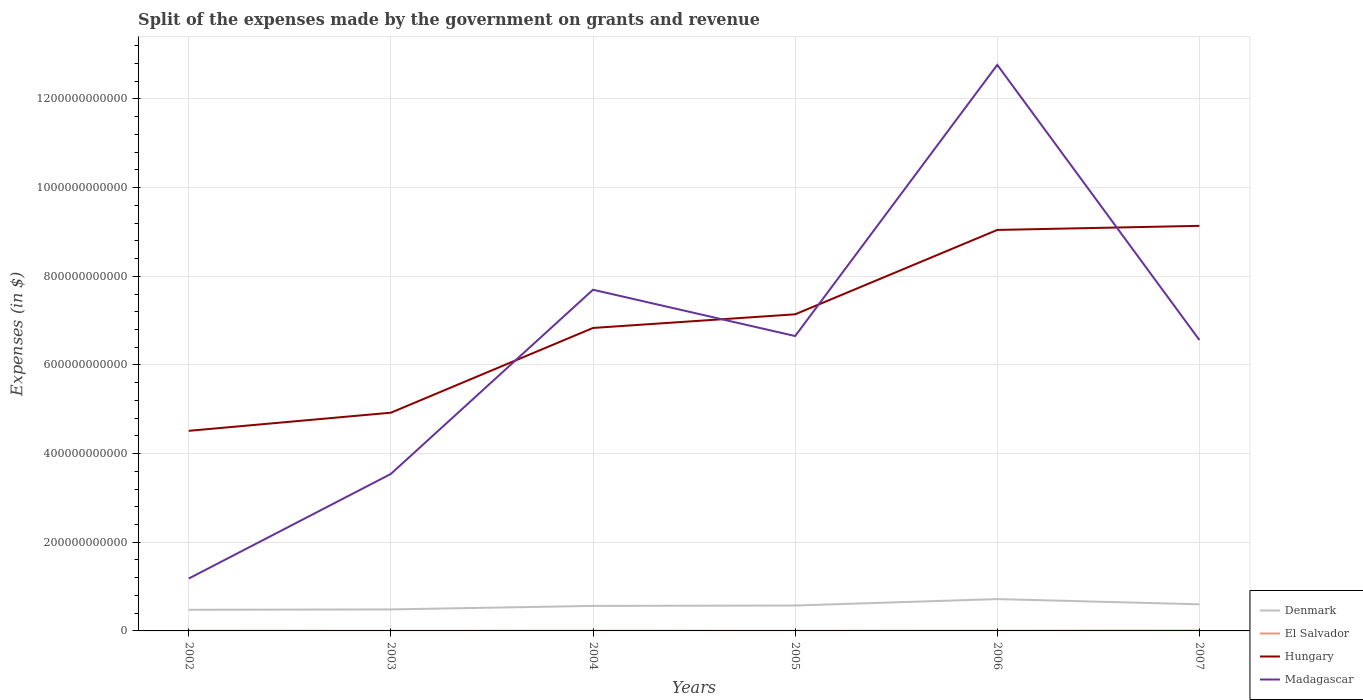How many different coloured lines are there?
Ensure brevity in your answer.  4. Across all years, what is the maximum expenses made by the government on grants and revenue in Madagascar?
Your answer should be compact. 1.18e+11. In which year was the expenses made by the government on grants and revenue in Denmark maximum?
Make the answer very short. 2002. What is the total expenses made by the government on grants and revenue in Denmark in the graph?
Offer a terse response. -1.24e+1. What is the difference between the highest and the second highest expenses made by the government on grants and revenue in Denmark?
Keep it short and to the point. 2.41e+1. How many years are there in the graph?
Keep it short and to the point. 6. What is the difference between two consecutive major ticks on the Y-axis?
Offer a terse response. 2.00e+11. Are the values on the major ticks of Y-axis written in scientific E-notation?
Make the answer very short. No. Where does the legend appear in the graph?
Provide a short and direct response. Bottom right. What is the title of the graph?
Provide a succinct answer. Split of the expenses made by the government on grants and revenue. Does "Puerto Rico" appear as one of the legend labels in the graph?
Your answer should be very brief. No. What is the label or title of the X-axis?
Keep it short and to the point. Years. What is the label or title of the Y-axis?
Your response must be concise. Expenses (in $). What is the Expenses (in $) of Denmark in 2002?
Offer a terse response. 4.77e+1. What is the Expenses (in $) of El Salvador in 2002?
Make the answer very short. 4.32e+08. What is the Expenses (in $) in Hungary in 2002?
Offer a terse response. 4.51e+11. What is the Expenses (in $) in Madagascar in 2002?
Give a very brief answer. 1.18e+11. What is the Expenses (in $) of Denmark in 2003?
Your response must be concise. 4.85e+1. What is the Expenses (in $) of El Salvador in 2003?
Provide a succinct answer. 2.89e+08. What is the Expenses (in $) in Hungary in 2003?
Make the answer very short. 4.92e+11. What is the Expenses (in $) of Madagascar in 2003?
Make the answer very short. 3.54e+11. What is the Expenses (in $) in Denmark in 2004?
Provide a succinct answer. 5.64e+1. What is the Expenses (in $) in El Salvador in 2004?
Your answer should be very brief. 3.98e+08. What is the Expenses (in $) of Hungary in 2004?
Offer a terse response. 6.83e+11. What is the Expenses (in $) of Madagascar in 2004?
Offer a very short reply. 7.70e+11. What is the Expenses (in $) in Denmark in 2005?
Provide a succinct answer. 5.73e+1. What is the Expenses (in $) in El Salvador in 2005?
Offer a terse response. 2.68e+08. What is the Expenses (in $) in Hungary in 2005?
Make the answer very short. 7.14e+11. What is the Expenses (in $) of Madagascar in 2005?
Provide a succinct answer. 6.65e+11. What is the Expenses (in $) of Denmark in 2006?
Your answer should be compact. 7.18e+1. What is the Expenses (in $) in El Salvador in 2006?
Provide a succinct answer. 4.71e+08. What is the Expenses (in $) of Hungary in 2006?
Provide a succinct answer. 9.05e+11. What is the Expenses (in $) in Madagascar in 2006?
Make the answer very short. 1.28e+12. What is the Expenses (in $) in Denmark in 2007?
Keep it short and to the point. 6.01e+1. What is the Expenses (in $) in El Salvador in 2007?
Provide a short and direct response. 7.05e+08. What is the Expenses (in $) in Hungary in 2007?
Provide a succinct answer. 9.14e+11. What is the Expenses (in $) of Madagascar in 2007?
Your answer should be compact. 6.56e+11. Across all years, what is the maximum Expenses (in $) in Denmark?
Provide a succinct answer. 7.18e+1. Across all years, what is the maximum Expenses (in $) of El Salvador?
Ensure brevity in your answer.  7.05e+08. Across all years, what is the maximum Expenses (in $) in Hungary?
Your answer should be very brief. 9.14e+11. Across all years, what is the maximum Expenses (in $) of Madagascar?
Offer a terse response. 1.28e+12. Across all years, what is the minimum Expenses (in $) of Denmark?
Ensure brevity in your answer.  4.77e+1. Across all years, what is the minimum Expenses (in $) in El Salvador?
Offer a very short reply. 2.68e+08. Across all years, what is the minimum Expenses (in $) in Hungary?
Ensure brevity in your answer.  4.51e+11. Across all years, what is the minimum Expenses (in $) of Madagascar?
Ensure brevity in your answer.  1.18e+11. What is the total Expenses (in $) of Denmark in the graph?
Provide a short and direct response. 3.42e+11. What is the total Expenses (in $) of El Salvador in the graph?
Give a very brief answer. 2.56e+09. What is the total Expenses (in $) of Hungary in the graph?
Your answer should be very brief. 4.16e+12. What is the total Expenses (in $) in Madagascar in the graph?
Offer a terse response. 3.84e+12. What is the difference between the Expenses (in $) in Denmark in 2002 and that in 2003?
Make the answer very short. -8.24e+08. What is the difference between the Expenses (in $) in El Salvador in 2002 and that in 2003?
Your response must be concise. 1.43e+08. What is the difference between the Expenses (in $) of Hungary in 2002 and that in 2003?
Offer a terse response. -4.09e+1. What is the difference between the Expenses (in $) in Madagascar in 2002 and that in 2003?
Offer a terse response. -2.36e+11. What is the difference between the Expenses (in $) in Denmark in 2002 and that in 2004?
Provide a succinct answer. -8.77e+09. What is the difference between the Expenses (in $) of El Salvador in 2002 and that in 2004?
Provide a succinct answer. 3.33e+07. What is the difference between the Expenses (in $) of Hungary in 2002 and that in 2004?
Your answer should be compact. -2.32e+11. What is the difference between the Expenses (in $) in Madagascar in 2002 and that in 2004?
Provide a succinct answer. -6.51e+11. What is the difference between the Expenses (in $) of Denmark in 2002 and that in 2005?
Ensure brevity in your answer.  -9.65e+09. What is the difference between the Expenses (in $) of El Salvador in 2002 and that in 2005?
Offer a terse response. 1.64e+08. What is the difference between the Expenses (in $) in Hungary in 2002 and that in 2005?
Offer a very short reply. -2.63e+11. What is the difference between the Expenses (in $) in Madagascar in 2002 and that in 2005?
Your response must be concise. -5.47e+11. What is the difference between the Expenses (in $) in Denmark in 2002 and that in 2006?
Give a very brief answer. -2.41e+1. What is the difference between the Expenses (in $) of El Salvador in 2002 and that in 2006?
Keep it short and to the point. -3.90e+07. What is the difference between the Expenses (in $) of Hungary in 2002 and that in 2006?
Your answer should be compact. -4.53e+11. What is the difference between the Expenses (in $) of Madagascar in 2002 and that in 2006?
Provide a short and direct response. -1.16e+12. What is the difference between the Expenses (in $) in Denmark in 2002 and that in 2007?
Keep it short and to the point. -1.24e+1. What is the difference between the Expenses (in $) in El Salvador in 2002 and that in 2007?
Give a very brief answer. -2.73e+08. What is the difference between the Expenses (in $) of Hungary in 2002 and that in 2007?
Provide a short and direct response. -4.62e+11. What is the difference between the Expenses (in $) of Madagascar in 2002 and that in 2007?
Provide a succinct answer. -5.38e+11. What is the difference between the Expenses (in $) in Denmark in 2003 and that in 2004?
Offer a very short reply. -7.95e+09. What is the difference between the Expenses (in $) of El Salvador in 2003 and that in 2004?
Keep it short and to the point. -1.09e+08. What is the difference between the Expenses (in $) in Hungary in 2003 and that in 2004?
Your answer should be compact. -1.91e+11. What is the difference between the Expenses (in $) in Madagascar in 2003 and that in 2004?
Your answer should be very brief. -4.15e+11. What is the difference between the Expenses (in $) in Denmark in 2003 and that in 2005?
Your answer should be very brief. -8.82e+09. What is the difference between the Expenses (in $) of El Salvador in 2003 and that in 2005?
Your answer should be very brief. 2.15e+07. What is the difference between the Expenses (in $) in Hungary in 2003 and that in 2005?
Make the answer very short. -2.22e+11. What is the difference between the Expenses (in $) of Madagascar in 2003 and that in 2005?
Your answer should be compact. -3.11e+11. What is the difference between the Expenses (in $) in Denmark in 2003 and that in 2006?
Make the answer very short. -2.33e+1. What is the difference between the Expenses (in $) in El Salvador in 2003 and that in 2006?
Your response must be concise. -1.82e+08. What is the difference between the Expenses (in $) of Hungary in 2003 and that in 2006?
Give a very brief answer. -4.12e+11. What is the difference between the Expenses (in $) of Madagascar in 2003 and that in 2006?
Your answer should be compact. -9.23e+11. What is the difference between the Expenses (in $) in Denmark in 2003 and that in 2007?
Your response must be concise. -1.16e+1. What is the difference between the Expenses (in $) of El Salvador in 2003 and that in 2007?
Give a very brief answer. -4.16e+08. What is the difference between the Expenses (in $) of Hungary in 2003 and that in 2007?
Provide a succinct answer. -4.22e+11. What is the difference between the Expenses (in $) of Madagascar in 2003 and that in 2007?
Give a very brief answer. -3.02e+11. What is the difference between the Expenses (in $) of Denmark in 2004 and that in 2005?
Ensure brevity in your answer.  -8.75e+08. What is the difference between the Expenses (in $) of El Salvador in 2004 and that in 2005?
Make the answer very short. 1.31e+08. What is the difference between the Expenses (in $) in Hungary in 2004 and that in 2005?
Make the answer very short. -3.08e+1. What is the difference between the Expenses (in $) in Madagascar in 2004 and that in 2005?
Your answer should be compact. 1.04e+11. What is the difference between the Expenses (in $) of Denmark in 2004 and that in 2006?
Your answer should be very brief. -1.54e+1. What is the difference between the Expenses (in $) of El Salvador in 2004 and that in 2006?
Offer a terse response. -7.23e+07. What is the difference between the Expenses (in $) in Hungary in 2004 and that in 2006?
Give a very brief answer. -2.21e+11. What is the difference between the Expenses (in $) in Madagascar in 2004 and that in 2006?
Your answer should be compact. -5.07e+11. What is the difference between the Expenses (in $) of Denmark in 2004 and that in 2007?
Provide a short and direct response. -3.62e+09. What is the difference between the Expenses (in $) of El Salvador in 2004 and that in 2007?
Give a very brief answer. -3.07e+08. What is the difference between the Expenses (in $) of Hungary in 2004 and that in 2007?
Keep it short and to the point. -2.30e+11. What is the difference between the Expenses (in $) of Madagascar in 2004 and that in 2007?
Make the answer very short. 1.13e+11. What is the difference between the Expenses (in $) of Denmark in 2005 and that in 2006?
Offer a very short reply. -1.45e+1. What is the difference between the Expenses (in $) in El Salvador in 2005 and that in 2006?
Offer a very short reply. -2.03e+08. What is the difference between the Expenses (in $) in Hungary in 2005 and that in 2006?
Provide a succinct answer. -1.90e+11. What is the difference between the Expenses (in $) of Madagascar in 2005 and that in 2006?
Provide a succinct answer. -6.12e+11. What is the difference between the Expenses (in $) of Denmark in 2005 and that in 2007?
Offer a terse response. -2.75e+09. What is the difference between the Expenses (in $) in El Salvador in 2005 and that in 2007?
Your response must be concise. -4.38e+08. What is the difference between the Expenses (in $) in Hungary in 2005 and that in 2007?
Make the answer very short. -2.00e+11. What is the difference between the Expenses (in $) of Madagascar in 2005 and that in 2007?
Make the answer very short. 8.96e+09. What is the difference between the Expenses (in $) of Denmark in 2006 and that in 2007?
Keep it short and to the point. 1.17e+1. What is the difference between the Expenses (in $) in El Salvador in 2006 and that in 2007?
Your answer should be compact. -2.34e+08. What is the difference between the Expenses (in $) of Hungary in 2006 and that in 2007?
Provide a succinct answer. -9.26e+09. What is the difference between the Expenses (in $) of Madagascar in 2006 and that in 2007?
Ensure brevity in your answer.  6.21e+11. What is the difference between the Expenses (in $) of Denmark in 2002 and the Expenses (in $) of El Salvador in 2003?
Your answer should be very brief. 4.74e+1. What is the difference between the Expenses (in $) in Denmark in 2002 and the Expenses (in $) in Hungary in 2003?
Offer a very short reply. -4.45e+11. What is the difference between the Expenses (in $) in Denmark in 2002 and the Expenses (in $) in Madagascar in 2003?
Give a very brief answer. -3.07e+11. What is the difference between the Expenses (in $) of El Salvador in 2002 and the Expenses (in $) of Hungary in 2003?
Your response must be concise. -4.92e+11. What is the difference between the Expenses (in $) in El Salvador in 2002 and the Expenses (in $) in Madagascar in 2003?
Provide a succinct answer. -3.54e+11. What is the difference between the Expenses (in $) in Hungary in 2002 and the Expenses (in $) in Madagascar in 2003?
Your answer should be very brief. 9.72e+1. What is the difference between the Expenses (in $) in Denmark in 2002 and the Expenses (in $) in El Salvador in 2004?
Ensure brevity in your answer.  4.73e+1. What is the difference between the Expenses (in $) in Denmark in 2002 and the Expenses (in $) in Hungary in 2004?
Offer a terse response. -6.36e+11. What is the difference between the Expenses (in $) of Denmark in 2002 and the Expenses (in $) of Madagascar in 2004?
Provide a short and direct response. -7.22e+11. What is the difference between the Expenses (in $) in El Salvador in 2002 and the Expenses (in $) in Hungary in 2004?
Provide a succinct answer. -6.83e+11. What is the difference between the Expenses (in $) in El Salvador in 2002 and the Expenses (in $) in Madagascar in 2004?
Provide a succinct answer. -7.69e+11. What is the difference between the Expenses (in $) in Hungary in 2002 and the Expenses (in $) in Madagascar in 2004?
Your answer should be very brief. -3.18e+11. What is the difference between the Expenses (in $) in Denmark in 2002 and the Expenses (in $) in El Salvador in 2005?
Ensure brevity in your answer.  4.74e+1. What is the difference between the Expenses (in $) of Denmark in 2002 and the Expenses (in $) of Hungary in 2005?
Make the answer very short. -6.67e+11. What is the difference between the Expenses (in $) in Denmark in 2002 and the Expenses (in $) in Madagascar in 2005?
Your answer should be very brief. -6.18e+11. What is the difference between the Expenses (in $) in El Salvador in 2002 and the Expenses (in $) in Hungary in 2005?
Keep it short and to the point. -7.14e+11. What is the difference between the Expenses (in $) in El Salvador in 2002 and the Expenses (in $) in Madagascar in 2005?
Offer a very short reply. -6.65e+11. What is the difference between the Expenses (in $) of Hungary in 2002 and the Expenses (in $) of Madagascar in 2005?
Your answer should be very brief. -2.14e+11. What is the difference between the Expenses (in $) of Denmark in 2002 and the Expenses (in $) of El Salvador in 2006?
Offer a very short reply. 4.72e+1. What is the difference between the Expenses (in $) in Denmark in 2002 and the Expenses (in $) in Hungary in 2006?
Offer a very short reply. -8.57e+11. What is the difference between the Expenses (in $) of Denmark in 2002 and the Expenses (in $) of Madagascar in 2006?
Keep it short and to the point. -1.23e+12. What is the difference between the Expenses (in $) of El Salvador in 2002 and the Expenses (in $) of Hungary in 2006?
Your answer should be very brief. -9.04e+11. What is the difference between the Expenses (in $) in El Salvador in 2002 and the Expenses (in $) in Madagascar in 2006?
Provide a succinct answer. -1.28e+12. What is the difference between the Expenses (in $) in Hungary in 2002 and the Expenses (in $) in Madagascar in 2006?
Provide a succinct answer. -8.26e+11. What is the difference between the Expenses (in $) in Denmark in 2002 and the Expenses (in $) in El Salvador in 2007?
Provide a succinct answer. 4.70e+1. What is the difference between the Expenses (in $) of Denmark in 2002 and the Expenses (in $) of Hungary in 2007?
Provide a short and direct response. -8.66e+11. What is the difference between the Expenses (in $) of Denmark in 2002 and the Expenses (in $) of Madagascar in 2007?
Make the answer very short. -6.09e+11. What is the difference between the Expenses (in $) in El Salvador in 2002 and the Expenses (in $) in Hungary in 2007?
Offer a terse response. -9.13e+11. What is the difference between the Expenses (in $) of El Salvador in 2002 and the Expenses (in $) of Madagascar in 2007?
Your response must be concise. -6.56e+11. What is the difference between the Expenses (in $) of Hungary in 2002 and the Expenses (in $) of Madagascar in 2007?
Provide a short and direct response. -2.05e+11. What is the difference between the Expenses (in $) of Denmark in 2003 and the Expenses (in $) of El Salvador in 2004?
Make the answer very short. 4.81e+1. What is the difference between the Expenses (in $) in Denmark in 2003 and the Expenses (in $) in Hungary in 2004?
Ensure brevity in your answer.  -6.35e+11. What is the difference between the Expenses (in $) in Denmark in 2003 and the Expenses (in $) in Madagascar in 2004?
Your answer should be very brief. -7.21e+11. What is the difference between the Expenses (in $) of El Salvador in 2003 and the Expenses (in $) of Hungary in 2004?
Give a very brief answer. -6.83e+11. What is the difference between the Expenses (in $) of El Salvador in 2003 and the Expenses (in $) of Madagascar in 2004?
Your response must be concise. -7.69e+11. What is the difference between the Expenses (in $) of Hungary in 2003 and the Expenses (in $) of Madagascar in 2004?
Your response must be concise. -2.77e+11. What is the difference between the Expenses (in $) of Denmark in 2003 and the Expenses (in $) of El Salvador in 2005?
Make the answer very short. 4.82e+1. What is the difference between the Expenses (in $) in Denmark in 2003 and the Expenses (in $) in Hungary in 2005?
Your response must be concise. -6.66e+11. What is the difference between the Expenses (in $) of Denmark in 2003 and the Expenses (in $) of Madagascar in 2005?
Ensure brevity in your answer.  -6.17e+11. What is the difference between the Expenses (in $) of El Salvador in 2003 and the Expenses (in $) of Hungary in 2005?
Provide a short and direct response. -7.14e+11. What is the difference between the Expenses (in $) of El Salvador in 2003 and the Expenses (in $) of Madagascar in 2005?
Keep it short and to the point. -6.65e+11. What is the difference between the Expenses (in $) in Hungary in 2003 and the Expenses (in $) in Madagascar in 2005?
Offer a very short reply. -1.73e+11. What is the difference between the Expenses (in $) of Denmark in 2003 and the Expenses (in $) of El Salvador in 2006?
Provide a short and direct response. 4.80e+1. What is the difference between the Expenses (in $) in Denmark in 2003 and the Expenses (in $) in Hungary in 2006?
Ensure brevity in your answer.  -8.56e+11. What is the difference between the Expenses (in $) of Denmark in 2003 and the Expenses (in $) of Madagascar in 2006?
Provide a short and direct response. -1.23e+12. What is the difference between the Expenses (in $) in El Salvador in 2003 and the Expenses (in $) in Hungary in 2006?
Offer a terse response. -9.04e+11. What is the difference between the Expenses (in $) of El Salvador in 2003 and the Expenses (in $) of Madagascar in 2006?
Provide a succinct answer. -1.28e+12. What is the difference between the Expenses (in $) in Hungary in 2003 and the Expenses (in $) in Madagascar in 2006?
Offer a terse response. -7.85e+11. What is the difference between the Expenses (in $) in Denmark in 2003 and the Expenses (in $) in El Salvador in 2007?
Provide a succinct answer. 4.78e+1. What is the difference between the Expenses (in $) of Denmark in 2003 and the Expenses (in $) of Hungary in 2007?
Your answer should be very brief. -8.65e+11. What is the difference between the Expenses (in $) in Denmark in 2003 and the Expenses (in $) in Madagascar in 2007?
Offer a terse response. -6.08e+11. What is the difference between the Expenses (in $) in El Salvador in 2003 and the Expenses (in $) in Hungary in 2007?
Give a very brief answer. -9.13e+11. What is the difference between the Expenses (in $) in El Salvador in 2003 and the Expenses (in $) in Madagascar in 2007?
Provide a short and direct response. -6.56e+11. What is the difference between the Expenses (in $) of Hungary in 2003 and the Expenses (in $) of Madagascar in 2007?
Offer a terse response. -1.64e+11. What is the difference between the Expenses (in $) in Denmark in 2004 and the Expenses (in $) in El Salvador in 2005?
Provide a short and direct response. 5.62e+1. What is the difference between the Expenses (in $) in Denmark in 2004 and the Expenses (in $) in Hungary in 2005?
Offer a very short reply. -6.58e+11. What is the difference between the Expenses (in $) in Denmark in 2004 and the Expenses (in $) in Madagascar in 2005?
Your response must be concise. -6.09e+11. What is the difference between the Expenses (in $) of El Salvador in 2004 and the Expenses (in $) of Hungary in 2005?
Give a very brief answer. -7.14e+11. What is the difference between the Expenses (in $) of El Salvador in 2004 and the Expenses (in $) of Madagascar in 2005?
Ensure brevity in your answer.  -6.65e+11. What is the difference between the Expenses (in $) of Hungary in 2004 and the Expenses (in $) of Madagascar in 2005?
Keep it short and to the point. 1.82e+1. What is the difference between the Expenses (in $) in Denmark in 2004 and the Expenses (in $) in El Salvador in 2006?
Make the answer very short. 5.60e+1. What is the difference between the Expenses (in $) of Denmark in 2004 and the Expenses (in $) of Hungary in 2006?
Offer a very short reply. -8.48e+11. What is the difference between the Expenses (in $) in Denmark in 2004 and the Expenses (in $) in Madagascar in 2006?
Your response must be concise. -1.22e+12. What is the difference between the Expenses (in $) of El Salvador in 2004 and the Expenses (in $) of Hungary in 2006?
Offer a terse response. -9.04e+11. What is the difference between the Expenses (in $) of El Salvador in 2004 and the Expenses (in $) of Madagascar in 2006?
Offer a very short reply. -1.28e+12. What is the difference between the Expenses (in $) of Hungary in 2004 and the Expenses (in $) of Madagascar in 2006?
Your answer should be compact. -5.93e+11. What is the difference between the Expenses (in $) in Denmark in 2004 and the Expenses (in $) in El Salvador in 2007?
Give a very brief answer. 5.57e+1. What is the difference between the Expenses (in $) in Denmark in 2004 and the Expenses (in $) in Hungary in 2007?
Your answer should be compact. -8.57e+11. What is the difference between the Expenses (in $) in Denmark in 2004 and the Expenses (in $) in Madagascar in 2007?
Give a very brief answer. -6.00e+11. What is the difference between the Expenses (in $) in El Salvador in 2004 and the Expenses (in $) in Hungary in 2007?
Give a very brief answer. -9.13e+11. What is the difference between the Expenses (in $) in El Salvador in 2004 and the Expenses (in $) in Madagascar in 2007?
Make the answer very short. -6.56e+11. What is the difference between the Expenses (in $) of Hungary in 2004 and the Expenses (in $) of Madagascar in 2007?
Provide a short and direct response. 2.72e+1. What is the difference between the Expenses (in $) in Denmark in 2005 and the Expenses (in $) in El Salvador in 2006?
Make the answer very short. 5.69e+1. What is the difference between the Expenses (in $) of Denmark in 2005 and the Expenses (in $) of Hungary in 2006?
Offer a terse response. -8.47e+11. What is the difference between the Expenses (in $) in Denmark in 2005 and the Expenses (in $) in Madagascar in 2006?
Give a very brief answer. -1.22e+12. What is the difference between the Expenses (in $) in El Salvador in 2005 and the Expenses (in $) in Hungary in 2006?
Your answer should be very brief. -9.04e+11. What is the difference between the Expenses (in $) in El Salvador in 2005 and the Expenses (in $) in Madagascar in 2006?
Your answer should be very brief. -1.28e+12. What is the difference between the Expenses (in $) of Hungary in 2005 and the Expenses (in $) of Madagascar in 2006?
Provide a short and direct response. -5.63e+11. What is the difference between the Expenses (in $) in Denmark in 2005 and the Expenses (in $) in El Salvador in 2007?
Your answer should be compact. 5.66e+1. What is the difference between the Expenses (in $) in Denmark in 2005 and the Expenses (in $) in Hungary in 2007?
Offer a very short reply. -8.56e+11. What is the difference between the Expenses (in $) in Denmark in 2005 and the Expenses (in $) in Madagascar in 2007?
Ensure brevity in your answer.  -5.99e+11. What is the difference between the Expenses (in $) of El Salvador in 2005 and the Expenses (in $) of Hungary in 2007?
Your response must be concise. -9.14e+11. What is the difference between the Expenses (in $) in El Salvador in 2005 and the Expenses (in $) in Madagascar in 2007?
Your answer should be very brief. -6.56e+11. What is the difference between the Expenses (in $) in Hungary in 2005 and the Expenses (in $) in Madagascar in 2007?
Make the answer very short. 5.80e+1. What is the difference between the Expenses (in $) of Denmark in 2006 and the Expenses (in $) of El Salvador in 2007?
Make the answer very short. 7.11e+1. What is the difference between the Expenses (in $) of Denmark in 2006 and the Expenses (in $) of Hungary in 2007?
Your answer should be compact. -8.42e+11. What is the difference between the Expenses (in $) in Denmark in 2006 and the Expenses (in $) in Madagascar in 2007?
Offer a very short reply. -5.84e+11. What is the difference between the Expenses (in $) of El Salvador in 2006 and the Expenses (in $) of Hungary in 2007?
Make the answer very short. -9.13e+11. What is the difference between the Expenses (in $) of El Salvador in 2006 and the Expenses (in $) of Madagascar in 2007?
Ensure brevity in your answer.  -6.56e+11. What is the difference between the Expenses (in $) in Hungary in 2006 and the Expenses (in $) in Madagascar in 2007?
Your answer should be compact. 2.48e+11. What is the average Expenses (in $) in Denmark per year?
Ensure brevity in your answer.  5.70e+1. What is the average Expenses (in $) in El Salvador per year?
Your answer should be very brief. 4.27e+08. What is the average Expenses (in $) in Hungary per year?
Offer a terse response. 6.93e+11. What is the average Expenses (in $) in Madagascar per year?
Your response must be concise. 6.40e+11. In the year 2002, what is the difference between the Expenses (in $) in Denmark and Expenses (in $) in El Salvador?
Make the answer very short. 4.72e+1. In the year 2002, what is the difference between the Expenses (in $) in Denmark and Expenses (in $) in Hungary?
Ensure brevity in your answer.  -4.04e+11. In the year 2002, what is the difference between the Expenses (in $) of Denmark and Expenses (in $) of Madagascar?
Keep it short and to the point. -7.05e+1. In the year 2002, what is the difference between the Expenses (in $) in El Salvador and Expenses (in $) in Hungary?
Make the answer very short. -4.51e+11. In the year 2002, what is the difference between the Expenses (in $) in El Salvador and Expenses (in $) in Madagascar?
Your answer should be very brief. -1.18e+11. In the year 2002, what is the difference between the Expenses (in $) in Hungary and Expenses (in $) in Madagascar?
Offer a terse response. 3.33e+11. In the year 2003, what is the difference between the Expenses (in $) of Denmark and Expenses (in $) of El Salvador?
Ensure brevity in your answer.  4.82e+1. In the year 2003, what is the difference between the Expenses (in $) in Denmark and Expenses (in $) in Hungary?
Ensure brevity in your answer.  -4.44e+11. In the year 2003, what is the difference between the Expenses (in $) of Denmark and Expenses (in $) of Madagascar?
Make the answer very short. -3.06e+11. In the year 2003, what is the difference between the Expenses (in $) in El Salvador and Expenses (in $) in Hungary?
Provide a short and direct response. -4.92e+11. In the year 2003, what is the difference between the Expenses (in $) in El Salvador and Expenses (in $) in Madagascar?
Keep it short and to the point. -3.54e+11. In the year 2003, what is the difference between the Expenses (in $) of Hungary and Expenses (in $) of Madagascar?
Ensure brevity in your answer.  1.38e+11. In the year 2004, what is the difference between the Expenses (in $) in Denmark and Expenses (in $) in El Salvador?
Your response must be concise. 5.61e+1. In the year 2004, what is the difference between the Expenses (in $) in Denmark and Expenses (in $) in Hungary?
Offer a very short reply. -6.27e+11. In the year 2004, what is the difference between the Expenses (in $) in Denmark and Expenses (in $) in Madagascar?
Provide a succinct answer. -7.13e+11. In the year 2004, what is the difference between the Expenses (in $) in El Salvador and Expenses (in $) in Hungary?
Ensure brevity in your answer.  -6.83e+11. In the year 2004, what is the difference between the Expenses (in $) of El Salvador and Expenses (in $) of Madagascar?
Keep it short and to the point. -7.69e+11. In the year 2004, what is the difference between the Expenses (in $) of Hungary and Expenses (in $) of Madagascar?
Give a very brief answer. -8.62e+1. In the year 2005, what is the difference between the Expenses (in $) in Denmark and Expenses (in $) in El Salvador?
Your response must be concise. 5.71e+1. In the year 2005, what is the difference between the Expenses (in $) in Denmark and Expenses (in $) in Hungary?
Give a very brief answer. -6.57e+11. In the year 2005, what is the difference between the Expenses (in $) of Denmark and Expenses (in $) of Madagascar?
Provide a succinct answer. -6.08e+11. In the year 2005, what is the difference between the Expenses (in $) of El Salvador and Expenses (in $) of Hungary?
Offer a very short reply. -7.14e+11. In the year 2005, what is the difference between the Expenses (in $) in El Salvador and Expenses (in $) in Madagascar?
Provide a short and direct response. -6.65e+11. In the year 2005, what is the difference between the Expenses (in $) of Hungary and Expenses (in $) of Madagascar?
Provide a succinct answer. 4.90e+1. In the year 2006, what is the difference between the Expenses (in $) of Denmark and Expenses (in $) of El Salvador?
Give a very brief answer. 7.13e+1. In the year 2006, what is the difference between the Expenses (in $) in Denmark and Expenses (in $) in Hungary?
Your answer should be compact. -8.33e+11. In the year 2006, what is the difference between the Expenses (in $) in Denmark and Expenses (in $) in Madagascar?
Offer a terse response. -1.21e+12. In the year 2006, what is the difference between the Expenses (in $) in El Salvador and Expenses (in $) in Hungary?
Offer a very short reply. -9.04e+11. In the year 2006, what is the difference between the Expenses (in $) in El Salvador and Expenses (in $) in Madagascar?
Your answer should be compact. -1.28e+12. In the year 2006, what is the difference between the Expenses (in $) of Hungary and Expenses (in $) of Madagascar?
Offer a very short reply. -3.72e+11. In the year 2007, what is the difference between the Expenses (in $) in Denmark and Expenses (in $) in El Salvador?
Keep it short and to the point. 5.94e+1. In the year 2007, what is the difference between the Expenses (in $) in Denmark and Expenses (in $) in Hungary?
Provide a succinct answer. -8.54e+11. In the year 2007, what is the difference between the Expenses (in $) of Denmark and Expenses (in $) of Madagascar?
Offer a very short reply. -5.96e+11. In the year 2007, what is the difference between the Expenses (in $) in El Salvador and Expenses (in $) in Hungary?
Your response must be concise. -9.13e+11. In the year 2007, what is the difference between the Expenses (in $) in El Salvador and Expenses (in $) in Madagascar?
Your response must be concise. -6.56e+11. In the year 2007, what is the difference between the Expenses (in $) of Hungary and Expenses (in $) of Madagascar?
Provide a succinct answer. 2.58e+11. What is the ratio of the Expenses (in $) in El Salvador in 2002 to that in 2003?
Make the answer very short. 1.49. What is the ratio of the Expenses (in $) of Hungary in 2002 to that in 2003?
Offer a very short reply. 0.92. What is the ratio of the Expenses (in $) of Madagascar in 2002 to that in 2003?
Give a very brief answer. 0.33. What is the ratio of the Expenses (in $) of Denmark in 2002 to that in 2004?
Provide a short and direct response. 0.84. What is the ratio of the Expenses (in $) in El Salvador in 2002 to that in 2004?
Offer a terse response. 1.08. What is the ratio of the Expenses (in $) of Hungary in 2002 to that in 2004?
Offer a very short reply. 0.66. What is the ratio of the Expenses (in $) in Madagascar in 2002 to that in 2004?
Your response must be concise. 0.15. What is the ratio of the Expenses (in $) of Denmark in 2002 to that in 2005?
Keep it short and to the point. 0.83. What is the ratio of the Expenses (in $) of El Salvador in 2002 to that in 2005?
Ensure brevity in your answer.  1.61. What is the ratio of the Expenses (in $) of Hungary in 2002 to that in 2005?
Your answer should be compact. 0.63. What is the ratio of the Expenses (in $) of Madagascar in 2002 to that in 2005?
Your answer should be very brief. 0.18. What is the ratio of the Expenses (in $) in Denmark in 2002 to that in 2006?
Your response must be concise. 0.66. What is the ratio of the Expenses (in $) of El Salvador in 2002 to that in 2006?
Keep it short and to the point. 0.92. What is the ratio of the Expenses (in $) in Hungary in 2002 to that in 2006?
Provide a succinct answer. 0.5. What is the ratio of the Expenses (in $) in Madagascar in 2002 to that in 2006?
Provide a succinct answer. 0.09. What is the ratio of the Expenses (in $) of Denmark in 2002 to that in 2007?
Make the answer very short. 0.79. What is the ratio of the Expenses (in $) in El Salvador in 2002 to that in 2007?
Provide a short and direct response. 0.61. What is the ratio of the Expenses (in $) of Hungary in 2002 to that in 2007?
Your answer should be very brief. 0.49. What is the ratio of the Expenses (in $) in Madagascar in 2002 to that in 2007?
Make the answer very short. 0.18. What is the ratio of the Expenses (in $) of Denmark in 2003 to that in 2004?
Give a very brief answer. 0.86. What is the ratio of the Expenses (in $) of El Salvador in 2003 to that in 2004?
Offer a very short reply. 0.73. What is the ratio of the Expenses (in $) of Hungary in 2003 to that in 2004?
Offer a terse response. 0.72. What is the ratio of the Expenses (in $) in Madagascar in 2003 to that in 2004?
Your answer should be very brief. 0.46. What is the ratio of the Expenses (in $) in Denmark in 2003 to that in 2005?
Give a very brief answer. 0.85. What is the ratio of the Expenses (in $) in El Salvador in 2003 to that in 2005?
Provide a short and direct response. 1.08. What is the ratio of the Expenses (in $) of Hungary in 2003 to that in 2005?
Your answer should be compact. 0.69. What is the ratio of the Expenses (in $) of Madagascar in 2003 to that in 2005?
Offer a terse response. 0.53. What is the ratio of the Expenses (in $) in Denmark in 2003 to that in 2006?
Offer a very short reply. 0.68. What is the ratio of the Expenses (in $) of El Salvador in 2003 to that in 2006?
Offer a very short reply. 0.61. What is the ratio of the Expenses (in $) of Hungary in 2003 to that in 2006?
Make the answer very short. 0.54. What is the ratio of the Expenses (in $) in Madagascar in 2003 to that in 2006?
Make the answer very short. 0.28. What is the ratio of the Expenses (in $) in Denmark in 2003 to that in 2007?
Provide a succinct answer. 0.81. What is the ratio of the Expenses (in $) of El Salvador in 2003 to that in 2007?
Offer a terse response. 0.41. What is the ratio of the Expenses (in $) of Hungary in 2003 to that in 2007?
Ensure brevity in your answer.  0.54. What is the ratio of the Expenses (in $) of Madagascar in 2003 to that in 2007?
Your answer should be very brief. 0.54. What is the ratio of the Expenses (in $) in Denmark in 2004 to that in 2005?
Make the answer very short. 0.98. What is the ratio of the Expenses (in $) of El Salvador in 2004 to that in 2005?
Your response must be concise. 1.49. What is the ratio of the Expenses (in $) of Hungary in 2004 to that in 2005?
Keep it short and to the point. 0.96. What is the ratio of the Expenses (in $) of Madagascar in 2004 to that in 2005?
Keep it short and to the point. 1.16. What is the ratio of the Expenses (in $) of Denmark in 2004 to that in 2006?
Keep it short and to the point. 0.79. What is the ratio of the Expenses (in $) in El Salvador in 2004 to that in 2006?
Make the answer very short. 0.85. What is the ratio of the Expenses (in $) in Hungary in 2004 to that in 2006?
Your answer should be compact. 0.76. What is the ratio of the Expenses (in $) of Madagascar in 2004 to that in 2006?
Offer a terse response. 0.6. What is the ratio of the Expenses (in $) in Denmark in 2004 to that in 2007?
Ensure brevity in your answer.  0.94. What is the ratio of the Expenses (in $) in El Salvador in 2004 to that in 2007?
Your answer should be compact. 0.57. What is the ratio of the Expenses (in $) in Hungary in 2004 to that in 2007?
Your answer should be compact. 0.75. What is the ratio of the Expenses (in $) of Madagascar in 2004 to that in 2007?
Provide a short and direct response. 1.17. What is the ratio of the Expenses (in $) of Denmark in 2005 to that in 2006?
Give a very brief answer. 0.8. What is the ratio of the Expenses (in $) in El Salvador in 2005 to that in 2006?
Provide a short and direct response. 0.57. What is the ratio of the Expenses (in $) of Hungary in 2005 to that in 2006?
Offer a very short reply. 0.79. What is the ratio of the Expenses (in $) of Madagascar in 2005 to that in 2006?
Your answer should be compact. 0.52. What is the ratio of the Expenses (in $) of Denmark in 2005 to that in 2007?
Offer a very short reply. 0.95. What is the ratio of the Expenses (in $) in El Salvador in 2005 to that in 2007?
Your answer should be very brief. 0.38. What is the ratio of the Expenses (in $) of Hungary in 2005 to that in 2007?
Your response must be concise. 0.78. What is the ratio of the Expenses (in $) in Madagascar in 2005 to that in 2007?
Your response must be concise. 1.01. What is the ratio of the Expenses (in $) in Denmark in 2006 to that in 2007?
Your response must be concise. 1.2. What is the ratio of the Expenses (in $) in El Salvador in 2006 to that in 2007?
Provide a succinct answer. 0.67. What is the ratio of the Expenses (in $) of Hungary in 2006 to that in 2007?
Provide a short and direct response. 0.99. What is the ratio of the Expenses (in $) in Madagascar in 2006 to that in 2007?
Offer a terse response. 1.95. What is the difference between the highest and the second highest Expenses (in $) of Denmark?
Provide a succinct answer. 1.17e+1. What is the difference between the highest and the second highest Expenses (in $) of El Salvador?
Your answer should be very brief. 2.34e+08. What is the difference between the highest and the second highest Expenses (in $) of Hungary?
Ensure brevity in your answer.  9.26e+09. What is the difference between the highest and the second highest Expenses (in $) of Madagascar?
Give a very brief answer. 5.07e+11. What is the difference between the highest and the lowest Expenses (in $) in Denmark?
Provide a succinct answer. 2.41e+1. What is the difference between the highest and the lowest Expenses (in $) of El Salvador?
Make the answer very short. 4.38e+08. What is the difference between the highest and the lowest Expenses (in $) of Hungary?
Give a very brief answer. 4.62e+11. What is the difference between the highest and the lowest Expenses (in $) of Madagascar?
Offer a very short reply. 1.16e+12. 